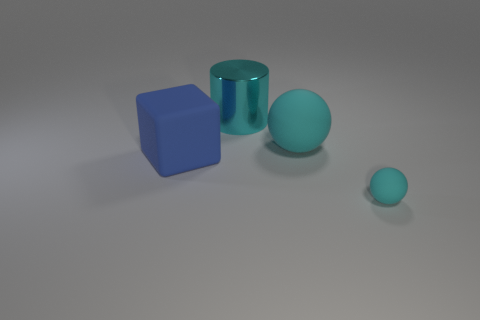Is there anything else that is made of the same material as the big cyan cylinder?
Provide a short and direct response. No. Are there any large cyan rubber spheres?
Give a very brief answer. Yes. There is a cyan object behind the large cyan rubber ball; what is its material?
Provide a short and direct response. Metal. What material is the other ball that is the same color as the small rubber ball?
Your response must be concise. Rubber. How many big objects are either brown matte objects or blue cubes?
Ensure brevity in your answer.  1. The small rubber thing is what color?
Keep it short and to the point. Cyan. Are there any cubes that are behind the big cyan thing that is on the right side of the cyan cylinder?
Keep it short and to the point. No. Is the number of cyan shiny cylinders that are in front of the block less than the number of tiny cyan balls?
Keep it short and to the point. Yes. Are the large cyan object that is in front of the cyan cylinder and the large cyan cylinder made of the same material?
Make the answer very short. No. What color is the ball that is the same material as the small cyan object?
Provide a succinct answer. Cyan. 